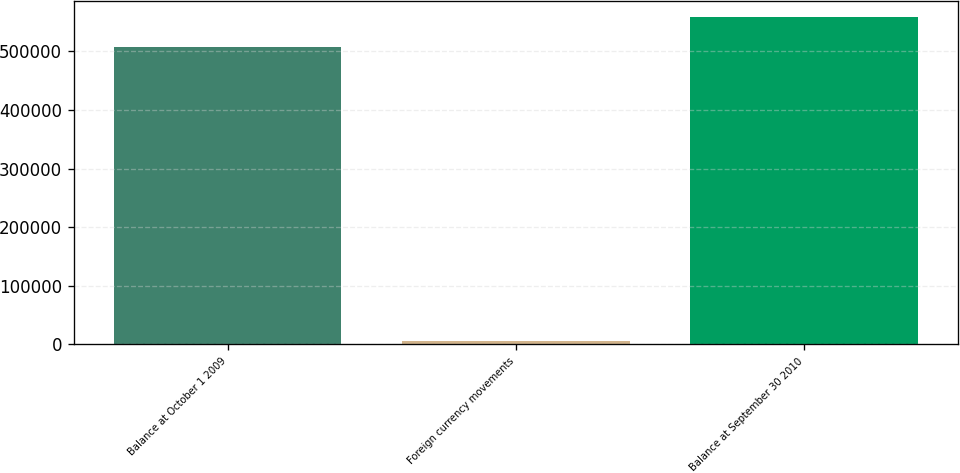Convert chart. <chart><loc_0><loc_0><loc_500><loc_500><bar_chart><fcel>Balance at October 1 2009<fcel>Foreign currency movements<fcel>Balance at September 30 2010<nl><fcel>507737<fcel>4719<fcel>558511<nl></chart> 